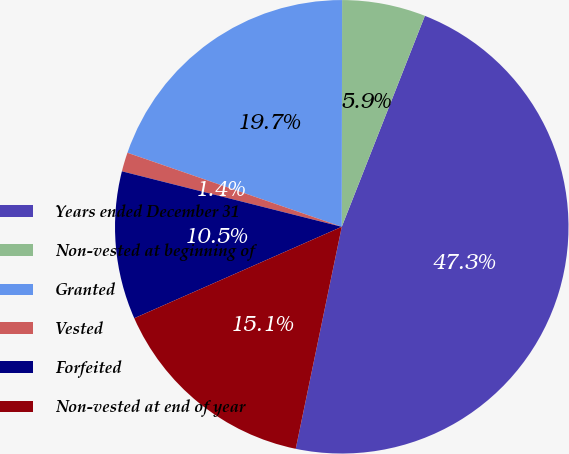Convert chart. <chart><loc_0><loc_0><loc_500><loc_500><pie_chart><fcel>Years ended December 31<fcel>Non-vested at beginning of<fcel>Granted<fcel>Vested<fcel>Forfeited<fcel>Non-vested at end of year<nl><fcel>47.28%<fcel>5.95%<fcel>19.73%<fcel>1.36%<fcel>10.54%<fcel>15.14%<nl></chart> 